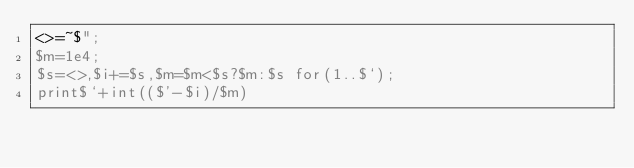Convert code to text. <code><loc_0><loc_0><loc_500><loc_500><_Perl_><>=~$";
$m=1e4;
$s=<>,$i+=$s,$m=$m<$s?$m:$s for(1..$`);
print$`+int(($'-$i)/$m)</code> 